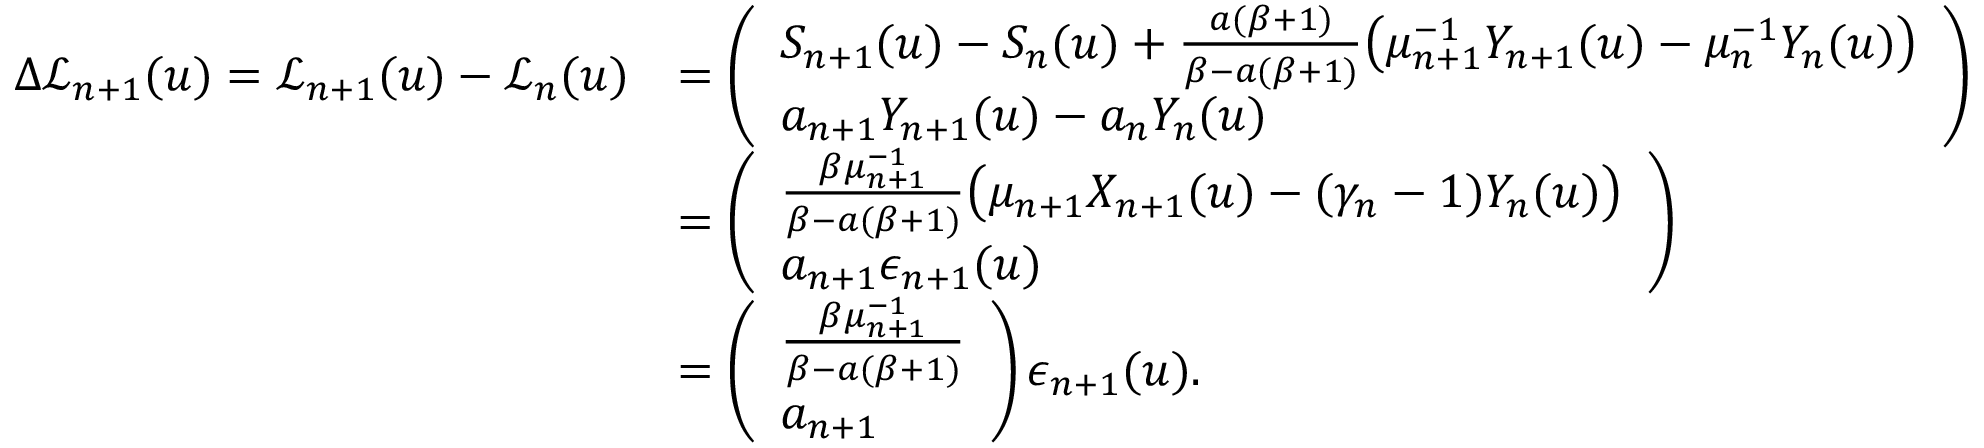Convert formula to latex. <formula><loc_0><loc_0><loc_500><loc_500>\begin{array} { r l } { \Delta \mathcal { L } _ { n + 1 } ( u ) = \mathcal { L } _ { n + 1 } ( u ) - \mathcal { L } _ { n } ( u ) } & { = \left ( \begin{array} { l } { S _ { n + 1 } ( u ) - S _ { n } ( u ) + \frac { a ( \beta + 1 ) } { \beta - a ( \beta + 1 ) } \left ( \mu _ { n + 1 } ^ { - 1 } Y _ { n + 1 } ( u ) - \mu _ { n } ^ { - 1 } Y _ { n } ( u ) \right ) } \\ { a _ { n + 1 } Y _ { n + 1 } ( u ) - a _ { n } Y _ { n } ( u ) } \end{array} \right ) } \\ & { = \left ( \begin{array} { l } { \frac { \beta \mu _ { n + 1 } ^ { - 1 } } { \beta - a ( \beta + 1 ) } \left ( \mu _ { n + 1 } X _ { n + 1 } ( u ) - ( \gamma _ { n } - 1 ) Y _ { n } ( u ) \right ) } \\ { a _ { n + 1 } \epsilon _ { n + 1 } ( u ) } \end{array} \right ) } \\ & { = \left ( \begin{array} { l } { \frac { \beta \mu _ { n + 1 } ^ { - 1 } } { \beta - a ( \beta + 1 ) } } \\ { a _ { n + 1 } } \end{array} \right ) \epsilon _ { n + 1 } ( u ) . } \end{array}</formula> 